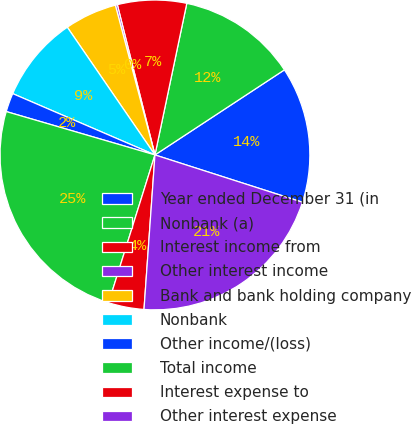Convert chart. <chart><loc_0><loc_0><loc_500><loc_500><pie_chart><fcel>Year ended December 31 (in<fcel>Nonbank (a)<fcel>Interest income from<fcel>Other interest income<fcel>Bank and bank holding company<fcel>Nonbank<fcel>Other income/(loss)<fcel>Total income<fcel>Interest expense to<fcel>Other interest expense<nl><fcel>14.19%<fcel>12.45%<fcel>7.2%<fcel>0.21%<fcel>5.46%<fcel>8.95%<fcel>1.96%<fcel>24.68%<fcel>3.71%<fcel>21.19%<nl></chart> 